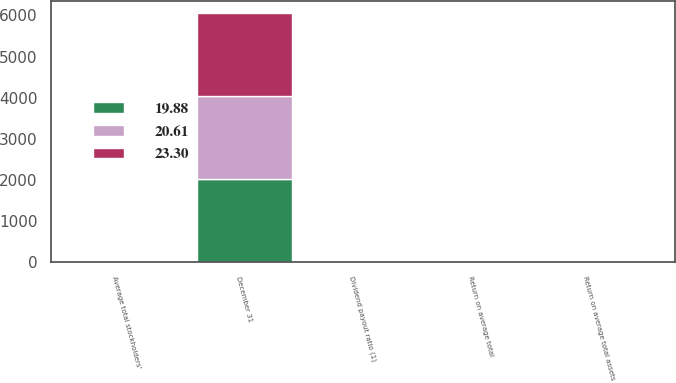Convert chart. <chart><loc_0><loc_0><loc_500><loc_500><stacked_bar_chart><ecel><fcel>December 31<fcel>Return on average total<fcel>Return on average total assets<fcel>Average total stockholders'<fcel>Dividend payout ratio (1)<nl><fcel>20.61<fcel>2017<fcel>13.41<fcel>1.03<fcel>7.71<fcel>19.88<nl><fcel>19.88<fcel>2016<fcel>12.55<fcel>0.94<fcel>7.49<fcel>20.61<nl><fcel>23.3<fcel>2015<fcel>11.45<fcel>0.87<fcel>7.61<fcel>23.3<nl></chart> 